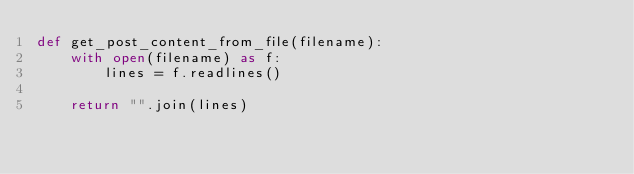<code> <loc_0><loc_0><loc_500><loc_500><_Python_>def get_post_content_from_file(filename):
    with open(filename) as f:
        lines = f.readlines()

    return "".join(lines)
</code> 